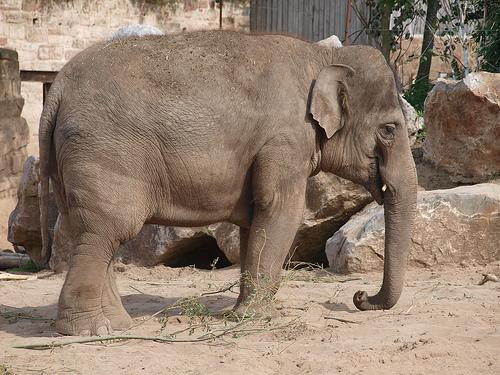Are there any tusk descriptions provided in the image context? If so, what are they? Yes, there is a small white tusk on the elephant's trunk. Can you identify any building structures in the image? There is a brick building and a metal shed behind the elephant. Estimate the total number of objects mentioned in the image description, including repetitive ones. Approximately 39 objects. List all the colors mentioned in the image's description regarding the elephant. Brown, gray, white, and tan. What is the primary animal featured in the image? An elephant. How many twigs or branches are mentioned in the image description and are they on or near the elephant? There are two twigs or branches mentioned, one is on the ground near the elephant and the other is in the elephant's mouth. Are there any hints about the kind of environment or location the image is set in? The image is set in an outdoor location with sand, rocks, trees, fencing, and buildings in the background. What is the position of the elephant's trunk and what is it doing? The elephant's trunk is on the ground, and the elephant is holding a stick in its mouth with the trunk. Describe some of the objects found lying on the ground in the picture. There is light tan sand, a small tree limb, a stick with a few green leaves, and a twig branch on the ground. What type of fencing and any accompanying structures can you find in the image background? There is a wooden fence with a post in the background. 